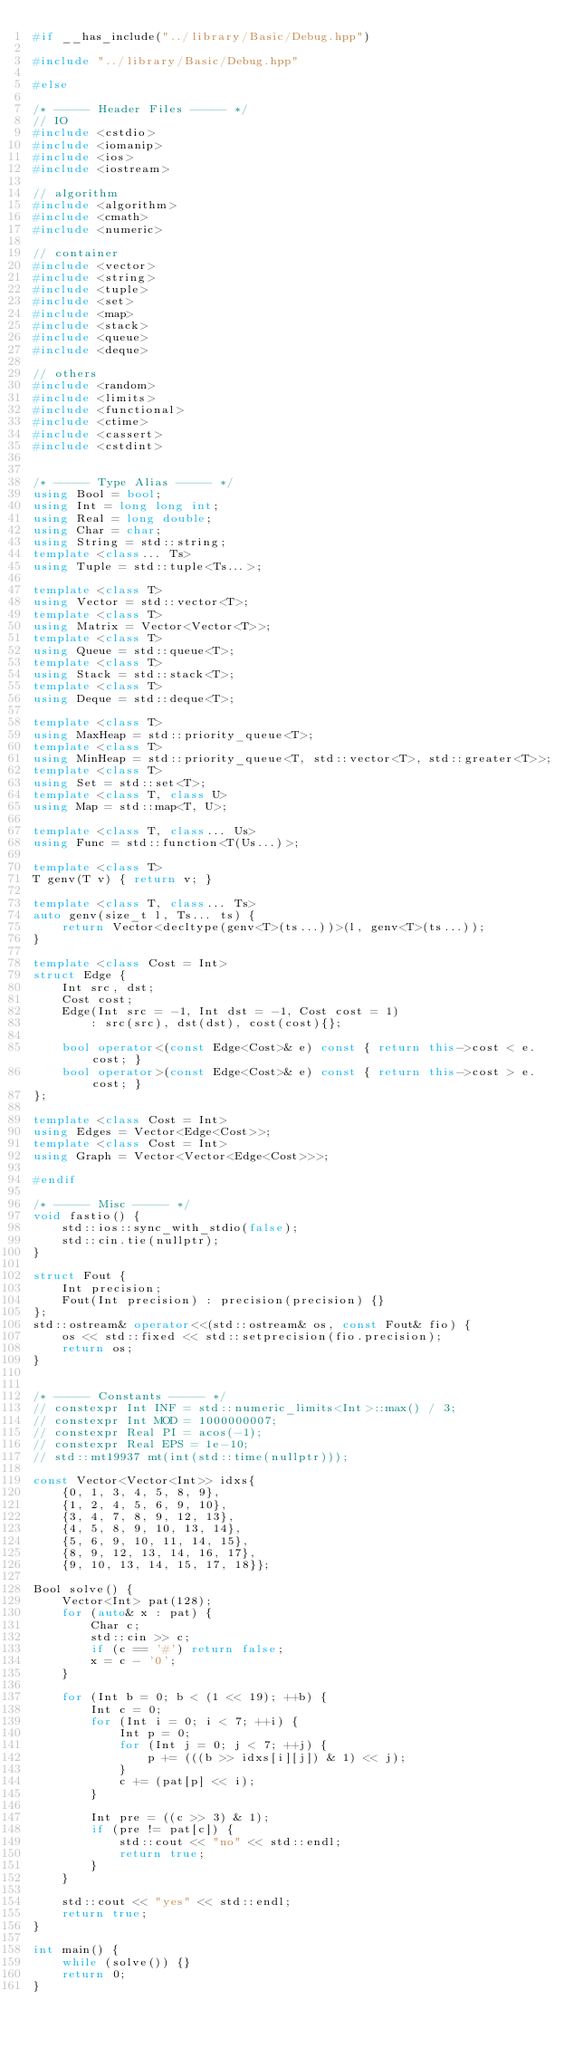Convert code to text. <code><loc_0><loc_0><loc_500><loc_500><_C++_>#if __has_include("../library/Basic/Debug.hpp")

#include "../library/Basic/Debug.hpp"

#else

/* ----- Header Files ----- */
// IO
#include <cstdio>
#include <iomanip>
#include <ios>
#include <iostream>

// algorithm
#include <algorithm>
#include <cmath>
#include <numeric>

// container
#include <vector>
#include <string>
#include <tuple>
#include <set>
#include <map>
#include <stack>
#include <queue>
#include <deque>

// others
#include <random>
#include <limits>
#include <functional>
#include <ctime>
#include <cassert>
#include <cstdint>


/* ----- Type Alias ----- */
using Bool = bool;
using Int = long long int;
using Real = long double;
using Char = char;
using String = std::string;
template <class... Ts>
using Tuple = std::tuple<Ts...>;

template <class T>
using Vector = std::vector<T>;
template <class T>
using Matrix = Vector<Vector<T>>;
template <class T>
using Queue = std::queue<T>;
template <class T>
using Stack = std::stack<T>;
template <class T>
using Deque = std::deque<T>;

template <class T>
using MaxHeap = std::priority_queue<T>;
template <class T>
using MinHeap = std::priority_queue<T, std::vector<T>, std::greater<T>>;
template <class T>
using Set = std::set<T>;
template <class T, class U>
using Map = std::map<T, U>;

template <class T, class... Us>
using Func = std::function<T(Us...)>;

template <class T>
T genv(T v) { return v; }

template <class T, class... Ts>
auto genv(size_t l, Ts... ts) {
    return Vector<decltype(genv<T>(ts...))>(l, genv<T>(ts...));
}

template <class Cost = Int>
struct Edge {
    Int src, dst;
    Cost cost;
    Edge(Int src = -1, Int dst = -1, Cost cost = 1)
        : src(src), dst(dst), cost(cost){};

    bool operator<(const Edge<Cost>& e) const { return this->cost < e.cost; }
    bool operator>(const Edge<Cost>& e) const { return this->cost > e.cost; }
};

template <class Cost = Int>
using Edges = Vector<Edge<Cost>>;
template <class Cost = Int>
using Graph = Vector<Vector<Edge<Cost>>>;

#endif

/* ----- Misc ----- */
void fastio() {
    std::ios::sync_with_stdio(false);
    std::cin.tie(nullptr);
}

struct Fout {
    Int precision;
    Fout(Int precision) : precision(precision) {}
};
std::ostream& operator<<(std::ostream& os, const Fout& fio) {
    os << std::fixed << std::setprecision(fio.precision);
    return os;
}


/* ----- Constants ----- */
// constexpr Int INF = std::numeric_limits<Int>::max() / 3;
// constexpr Int MOD = 1000000007;
// constexpr Real PI = acos(-1);
// constexpr Real EPS = 1e-10;
// std::mt19937 mt(int(std::time(nullptr)));

const Vector<Vector<Int>> idxs{
    {0, 1, 3, 4, 5, 8, 9},
    {1, 2, 4, 5, 6, 9, 10},
    {3, 4, 7, 8, 9, 12, 13},
    {4, 5, 8, 9, 10, 13, 14},
    {5, 6, 9, 10, 11, 14, 15},
    {8, 9, 12, 13, 14, 16, 17},
    {9, 10, 13, 14, 15, 17, 18}};

Bool solve() {
    Vector<Int> pat(128);
    for (auto& x : pat) {
        Char c;
        std::cin >> c;
        if (c == '#') return false;
        x = c - '0';
    }

    for (Int b = 0; b < (1 << 19); ++b) {
        Int c = 0;
        for (Int i = 0; i < 7; ++i) {
            Int p = 0;
            for (Int j = 0; j < 7; ++j) {
                p += (((b >> idxs[i][j]) & 1) << j);
            }
            c += (pat[p] << i);
        }

        Int pre = ((c >> 3) & 1);
        if (pre != pat[c]) {
            std::cout << "no" << std::endl;
            return true;
        }
    }

    std::cout << "yes" << std::endl;
    return true;
}

int main() {
    while (solve()) {}
    return 0;
}

</code> 